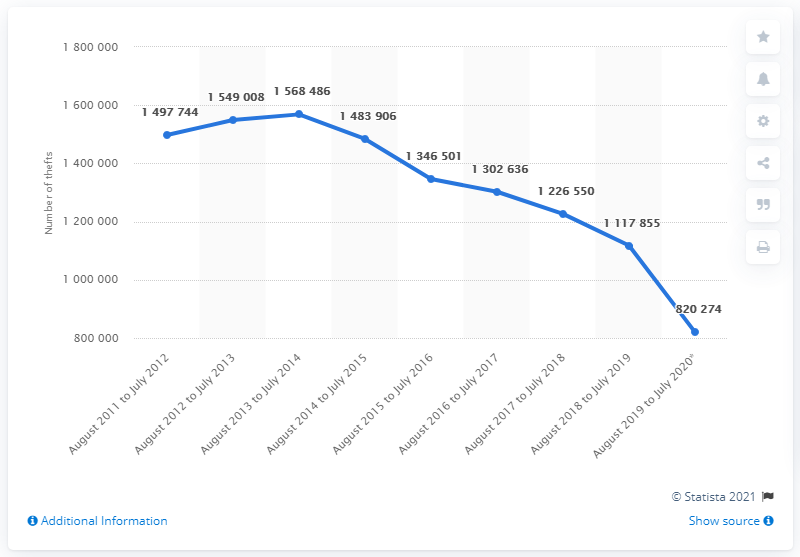Specify some key components in this picture. The number of thefts that occurred between August 2011 and July 2012 was 149,774. 